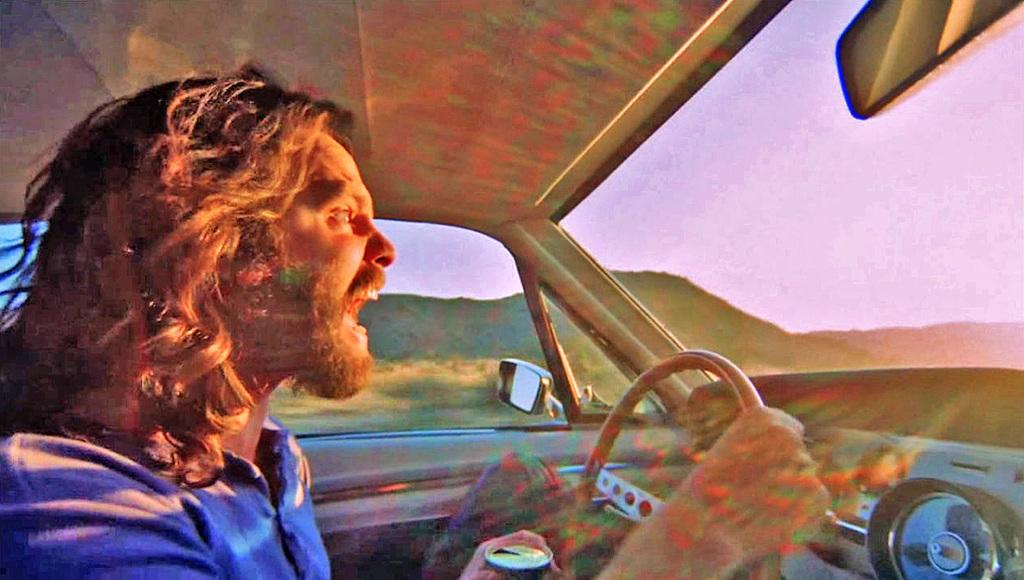What is the main subject of the image? There is a person driving a car in the image. What can be seen in the background of the image? Mountains and the sky are visible in the background of the image. What type of club is being used to protest in the image? There is no club or protest present in the image; it features a person driving a car with mountains and the sky in the background. 